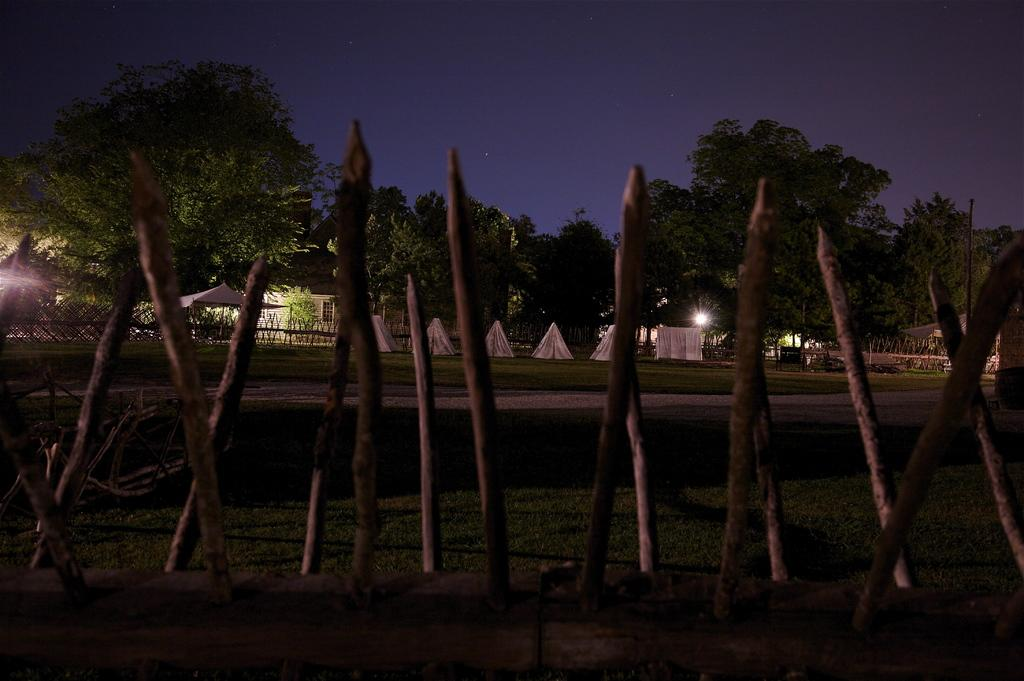What type of material is used for the logs in the image? The logs in the image are made of wood. What structures are visible on the grass in the image? There are tents on the grass in the image. What can be seen in the background of the image? Trees, a house, a fence, and the sky are visible in the background of the image. What type of pest can be seen crawling on the tents in the image? There is no pest visible on the tents in the image. What type of print can be seen on the house in the image? There is no print visible on the house in the image; the house is simply a background element. 